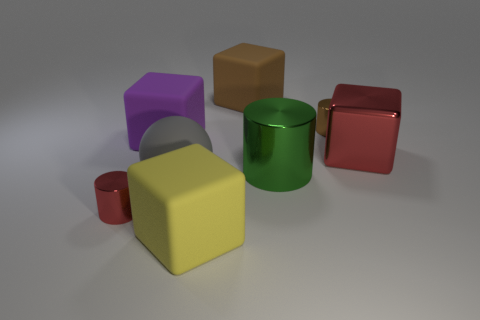There is a red metallic thing left of the large gray sphere; what number of large cylinders are in front of it?
Provide a short and direct response. 0. There is a gray ball that is the same size as the yellow object; what is its material?
Make the answer very short. Rubber. How many other things are made of the same material as the big cylinder?
Give a very brief answer. 3. How many large brown things are left of the tiny red cylinder?
Your response must be concise. 0. How many cylinders are either red shiny things or tiny brown shiny things?
Offer a very short reply. 2. There is a metallic cylinder that is in front of the large red thing and on the right side of the tiny red object; what is its size?
Keep it short and to the point. Large. How many other objects are the same color as the large metallic cube?
Ensure brevity in your answer.  1. Do the tiny red cylinder and the block to the right of the big green object have the same material?
Offer a very short reply. Yes. What number of things are tiny metal cylinders that are to the left of the brown rubber cube or red blocks?
Make the answer very short. 2. What shape is the rubber object that is both behind the gray rubber sphere and in front of the brown metal thing?
Keep it short and to the point. Cube. 